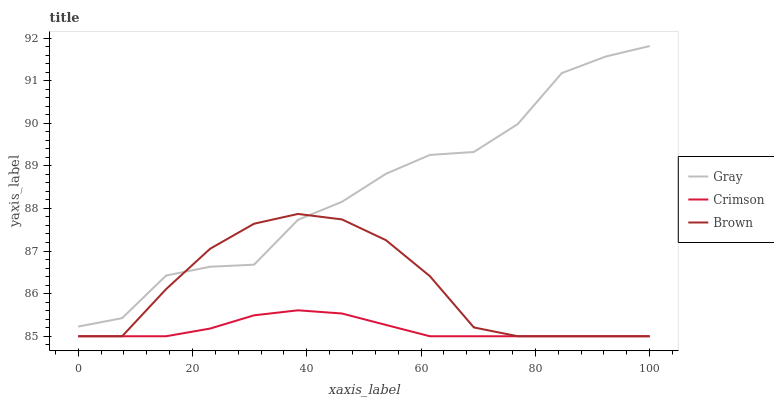Does Crimson have the minimum area under the curve?
Answer yes or no. Yes. Does Gray have the maximum area under the curve?
Answer yes or no. Yes. Does Brown have the minimum area under the curve?
Answer yes or no. No. Does Brown have the maximum area under the curve?
Answer yes or no. No. Is Crimson the smoothest?
Answer yes or no. Yes. Is Gray the roughest?
Answer yes or no. Yes. Is Brown the smoothest?
Answer yes or no. No. Is Brown the roughest?
Answer yes or no. No. Does Crimson have the lowest value?
Answer yes or no. Yes. Does Gray have the lowest value?
Answer yes or no. No. Does Gray have the highest value?
Answer yes or no. Yes. Does Brown have the highest value?
Answer yes or no. No. Is Crimson less than Gray?
Answer yes or no. Yes. Is Gray greater than Crimson?
Answer yes or no. Yes. Does Brown intersect Gray?
Answer yes or no. Yes. Is Brown less than Gray?
Answer yes or no. No. Is Brown greater than Gray?
Answer yes or no. No. Does Crimson intersect Gray?
Answer yes or no. No. 